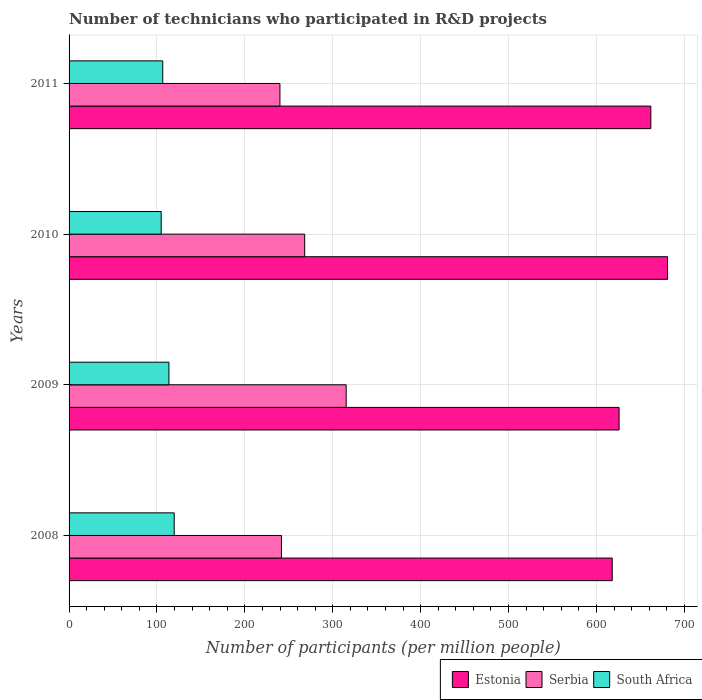How many different coloured bars are there?
Provide a succinct answer. 3. Are the number of bars per tick equal to the number of legend labels?
Provide a succinct answer. Yes. Are the number of bars on each tick of the Y-axis equal?
Your response must be concise. Yes. How many bars are there on the 3rd tick from the bottom?
Make the answer very short. 3. In how many cases, is the number of bars for a given year not equal to the number of legend labels?
Your response must be concise. 0. What is the number of technicians who participated in R&D projects in Estonia in 2009?
Provide a succinct answer. 625.74. Across all years, what is the maximum number of technicians who participated in R&D projects in South Africa?
Offer a very short reply. 119.61. Across all years, what is the minimum number of technicians who participated in R&D projects in South Africa?
Give a very brief answer. 104.79. In which year was the number of technicians who participated in R&D projects in South Africa maximum?
Keep it short and to the point. 2008. In which year was the number of technicians who participated in R&D projects in South Africa minimum?
Your answer should be compact. 2010. What is the total number of technicians who participated in R&D projects in Serbia in the graph?
Your response must be concise. 1064.76. What is the difference between the number of technicians who participated in R&D projects in Serbia in 2008 and that in 2011?
Your answer should be very brief. 1.69. What is the difference between the number of technicians who participated in R&D projects in Estonia in 2010 and the number of technicians who participated in R&D projects in Serbia in 2008?
Offer a terse response. 439.3. What is the average number of technicians who participated in R&D projects in South Africa per year?
Provide a short and direct response. 111.14. In the year 2011, what is the difference between the number of technicians who participated in R&D projects in South Africa and number of technicians who participated in R&D projects in Estonia?
Provide a succinct answer. -555.29. In how many years, is the number of technicians who participated in R&D projects in Estonia greater than 680 ?
Ensure brevity in your answer.  1. What is the ratio of the number of technicians who participated in R&D projects in Serbia in 2009 to that in 2010?
Give a very brief answer. 1.18. Is the number of technicians who participated in R&D projects in Serbia in 2010 less than that in 2011?
Ensure brevity in your answer.  No. What is the difference between the highest and the second highest number of technicians who participated in R&D projects in South Africa?
Your response must be concise. 6.02. What is the difference between the highest and the lowest number of technicians who participated in R&D projects in Serbia?
Your response must be concise. 75.36. In how many years, is the number of technicians who participated in R&D projects in Serbia greater than the average number of technicians who participated in R&D projects in Serbia taken over all years?
Give a very brief answer. 2. What does the 3rd bar from the top in 2011 represents?
Your answer should be very brief. Estonia. What does the 3rd bar from the bottom in 2008 represents?
Provide a succinct answer. South Africa. Is it the case that in every year, the sum of the number of technicians who participated in R&D projects in Serbia and number of technicians who participated in R&D projects in Estonia is greater than the number of technicians who participated in R&D projects in South Africa?
Provide a short and direct response. Yes. How many bars are there?
Offer a terse response. 12. Are all the bars in the graph horizontal?
Ensure brevity in your answer.  Yes. How many years are there in the graph?
Offer a terse response. 4. What is the difference between two consecutive major ticks on the X-axis?
Offer a very short reply. 100. Are the values on the major ticks of X-axis written in scientific E-notation?
Your answer should be compact. No. Does the graph contain any zero values?
Offer a terse response. No. Does the graph contain grids?
Your response must be concise. Yes. How many legend labels are there?
Your answer should be very brief. 3. How are the legend labels stacked?
Keep it short and to the point. Horizontal. What is the title of the graph?
Provide a succinct answer. Number of technicians who participated in R&D projects. What is the label or title of the X-axis?
Offer a terse response. Number of participants (per million people). What is the Number of participants (per million people) of Estonia in 2008?
Your answer should be very brief. 617.94. What is the Number of participants (per million people) of Serbia in 2008?
Your response must be concise. 241.58. What is the Number of participants (per million people) in South Africa in 2008?
Keep it short and to the point. 119.61. What is the Number of participants (per million people) of Estonia in 2009?
Offer a terse response. 625.74. What is the Number of participants (per million people) in Serbia in 2009?
Make the answer very short. 315.25. What is the Number of participants (per million people) in South Africa in 2009?
Provide a succinct answer. 113.59. What is the Number of participants (per million people) in Estonia in 2010?
Your answer should be very brief. 680.89. What is the Number of participants (per million people) in Serbia in 2010?
Make the answer very short. 268.03. What is the Number of participants (per million people) in South Africa in 2010?
Provide a short and direct response. 104.79. What is the Number of participants (per million people) in Estonia in 2011?
Make the answer very short. 661.86. What is the Number of participants (per million people) in Serbia in 2011?
Your answer should be very brief. 239.9. What is the Number of participants (per million people) in South Africa in 2011?
Your response must be concise. 106.57. Across all years, what is the maximum Number of participants (per million people) in Estonia?
Provide a succinct answer. 680.89. Across all years, what is the maximum Number of participants (per million people) of Serbia?
Your response must be concise. 315.25. Across all years, what is the maximum Number of participants (per million people) of South Africa?
Your answer should be compact. 119.61. Across all years, what is the minimum Number of participants (per million people) in Estonia?
Your answer should be very brief. 617.94. Across all years, what is the minimum Number of participants (per million people) of Serbia?
Your answer should be compact. 239.9. Across all years, what is the minimum Number of participants (per million people) of South Africa?
Keep it short and to the point. 104.79. What is the total Number of participants (per million people) in Estonia in the graph?
Provide a succinct answer. 2586.43. What is the total Number of participants (per million people) in Serbia in the graph?
Your answer should be compact. 1064.76. What is the total Number of participants (per million people) in South Africa in the graph?
Keep it short and to the point. 444.57. What is the difference between the Number of participants (per million people) of Estonia in 2008 and that in 2009?
Offer a terse response. -7.8. What is the difference between the Number of participants (per million people) of Serbia in 2008 and that in 2009?
Offer a very short reply. -73.67. What is the difference between the Number of participants (per million people) in South Africa in 2008 and that in 2009?
Make the answer very short. 6.02. What is the difference between the Number of participants (per million people) in Estonia in 2008 and that in 2010?
Your answer should be compact. -62.95. What is the difference between the Number of participants (per million people) of Serbia in 2008 and that in 2010?
Your answer should be very brief. -26.45. What is the difference between the Number of participants (per million people) in South Africa in 2008 and that in 2010?
Make the answer very short. 14.82. What is the difference between the Number of participants (per million people) of Estonia in 2008 and that in 2011?
Give a very brief answer. -43.93. What is the difference between the Number of participants (per million people) of Serbia in 2008 and that in 2011?
Make the answer very short. 1.69. What is the difference between the Number of participants (per million people) of South Africa in 2008 and that in 2011?
Ensure brevity in your answer.  13.04. What is the difference between the Number of participants (per million people) of Estonia in 2009 and that in 2010?
Your response must be concise. -55.14. What is the difference between the Number of participants (per million people) of Serbia in 2009 and that in 2010?
Provide a succinct answer. 47.22. What is the difference between the Number of participants (per million people) of South Africa in 2009 and that in 2010?
Provide a succinct answer. 8.8. What is the difference between the Number of participants (per million people) in Estonia in 2009 and that in 2011?
Keep it short and to the point. -36.12. What is the difference between the Number of participants (per million people) of Serbia in 2009 and that in 2011?
Give a very brief answer. 75.36. What is the difference between the Number of participants (per million people) in South Africa in 2009 and that in 2011?
Your answer should be very brief. 7.02. What is the difference between the Number of participants (per million people) in Estonia in 2010 and that in 2011?
Give a very brief answer. 19.02. What is the difference between the Number of participants (per million people) in Serbia in 2010 and that in 2011?
Give a very brief answer. 28.13. What is the difference between the Number of participants (per million people) in South Africa in 2010 and that in 2011?
Your response must be concise. -1.78. What is the difference between the Number of participants (per million people) in Estonia in 2008 and the Number of participants (per million people) in Serbia in 2009?
Provide a succinct answer. 302.69. What is the difference between the Number of participants (per million people) of Estonia in 2008 and the Number of participants (per million people) of South Africa in 2009?
Your response must be concise. 504.35. What is the difference between the Number of participants (per million people) in Serbia in 2008 and the Number of participants (per million people) in South Africa in 2009?
Offer a terse response. 127.99. What is the difference between the Number of participants (per million people) in Estonia in 2008 and the Number of participants (per million people) in Serbia in 2010?
Make the answer very short. 349.91. What is the difference between the Number of participants (per million people) in Estonia in 2008 and the Number of participants (per million people) in South Africa in 2010?
Ensure brevity in your answer.  513.14. What is the difference between the Number of participants (per million people) in Serbia in 2008 and the Number of participants (per million people) in South Africa in 2010?
Give a very brief answer. 136.79. What is the difference between the Number of participants (per million people) in Estonia in 2008 and the Number of participants (per million people) in Serbia in 2011?
Offer a very short reply. 378.04. What is the difference between the Number of participants (per million people) of Estonia in 2008 and the Number of participants (per million people) of South Africa in 2011?
Ensure brevity in your answer.  511.37. What is the difference between the Number of participants (per million people) of Serbia in 2008 and the Number of participants (per million people) of South Africa in 2011?
Give a very brief answer. 135.01. What is the difference between the Number of participants (per million people) in Estonia in 2009 and the Number of participants (per million people) in Serbia in 2010?
Give a very brief answer. 357.71. What is the difference between the Number of participants (per million people) of Estonia in 2009 and the Number of participants (per million people) of South Africa in 2010?
Provide a short and direct response. 520.95. What is the difference between the Number of participants (per million people) in Serbia in 2009 and the Number of participants (per million people) in South Africa in 2010?
Your response must be concise. 210.46. What is the difference between the Number of participants (per million people) in Estonia in 2009 and the Number of participants (per million people) in Serbia in 2011?
Ensure brevity in your answer.  385.85. What is the difference between the Number of participants (per million people) in Estonia in 2009 and the Number of participants (per million people) in South Africa in 2011?
Keep it short and to the point. 519.17. What is the difference between the Number of participants (per million people) of Serbia in 2009 and the Number of participants (per million people) of South Africa in 2011?
Give a very brief answer. 208.68. What is the difference between the Number of participants (per million people) in Estonia in 2010 and the Number of participants (per million people) in Serbia in 2011?
Provide a succinct answer. 440.99. What is the difference between the Number of participants (per million people) in Estonia in 2010 and the Number of participants (per million people) in South Africa in 2011?
Your response must be concise. 574.32. What is the difference between the Number of participants (per million people) in Serbia in 2010 and the Number of participants (per million people) in South Africa in 2011?
Your answer should be very brief. 161.46. What is the average Number of participants (per million people) in Estonia per year?
Make the answer very short. 646.61. What is the average Number of participants (per million people) in Serbia per year?
Your response must be concise. 266.19. What is the average Number of participants (per million people) of South Africa per year?
Your answer should be very brief. 111.14. In the year 2008, what is the difference between the Number of participants (per million people) in Estonia and Number of participants (per million people) in Serbia?
Offer a very short reply. 376.36. In the year 2008, what is the difference between the Number of participants (per million people) of Estonia and Number of participants (per million people) of South Africa?
Your answer should be very brief. 498.32. In the year 2008, what is the difference between the Number of participants (per million people) of Serbia and Number of participants (per million people) of South Africa?
Keep it short and to the point. 121.97. In the year 2009, what is the difference between the Number of participants (per million people) in Estonia and Number of participants (per million people) in Serbia?
Provide a short and direct response. 310.49. In the year 2009, what is the difference between the Number of participants (per million people) in Estonia and Number of participants (per million people) in South Africa?
Your answer should be very brief. 512.15. In the year 2009, what is the difference between the Number of participants (per million people) of Serbia and Number of participants (per million people) of South Africa?
Offer a very short reply. 201.66. In the year 2010, what is the difference between the Number of participants (per million people) of Estonia and Number of participants (per million people) of Serbia?
Give a very brief answer. 412.86. In the year 2010, what is the difference between the Number of participants (per million people) of Estonia and Number of participants (per million people) of South Africa?
Your answer should be compact. 576.09. In the year 2010, what is the difference between the Number of participants (per million people) of Serbia and Number of participants (per million people) of South Africa?
Your answer should be very brief. 163.24. In the year 2011, what is the difference between the Number of participants (per million people) in Estonia and Number of participants (per million people) in Serbia?
Your answer should be compact. 421.97. In the year 2011, what is the difference between the Number of participants (per million people) of Estonia and Number of participants (per million people) of South Africa?
Give a very brief answer. 555.29. In the year 2011, what is the difference between the Number of participants (per million people) in Serbia and Number of participants (per million people) in South Africa?
Your response must be concise. 133.33. What is the ratio of the Number of participants (per million people) of Estonia in 2008 to that in 2009?
Ensure brevity in your answer.  0.99. What is the ratio of the Number of participants (per million people) of Serbia in 2008 to that in 2009?
Keep it short and to the point. 0.77. What is the ratio of the Number of participants (per million people) of South Africa in 2008 to that in 2009?
Provide a short and direct response. 1.05. What is the ratio of the Number of participants (per million people) of Estonia in 2008 to that in 2010?
Give a very brief answer. 0.91. What is the ratio of the Number of participants (per million people) of Serbia in 2008 to that in 2010?
Your response must be concise. 0.9. What is the ratio of the Number of participants (per million people) of South Africa in 2008 to that in 2010?
Offer a very short reply. 1.14. What is the ratio of the Number of participants (per million people) of Estonia in 2008 to that in 2011?
Keep it short and to the point. 0.93. What is the ratio of the Number of participants (per million people) of Serbia in 2008 to that in 2011?
Your answer should be very brief. 1.01. What is the ratio of the Number of participants (per million people) of South Africa in 2008 to that in 2011?
Give a very brief answer. 1.12. What is the ratio of the Number of participants (per million people) of Estonia in 2009 to that in 2010?
Your response must be concise. 0.92. What is the ratio of the Number of participants (per million people) of Serbia in 2009 to that in 2010?
Keep it short and to the point. 1.18. What is the ratio of the Number of participants (per million people) in South Africa in 2009 to that in 2010?
Keep it short and to the point. 1.08. What is the ratio of the Number of participants (per million people) in Estonia in 2009 to that in 2011?
Your response must be concise. 0.95. What is the ratio of the Number of participants (per million people) in Serbia in 2009 to that in 2011?
Offer a very short reply. 1.31. What is the ratio of the Number of participants (per million people) of South Africa in 2009 to that in 2011?
Provide a succinct answer. 1.07. What is the ratio of the Number of participants (per million people) of Estonia in 2010 to that in 2011?
Your response must be concise. 1.03. What is the ratio of the Number of participants (per million people) of Serbia in 2010 to that in 2011?
Your answer should be very brief. 1.12. What is the ratio of the Number of participants (per million people) of South Africa in 2010 to that in 2011?
Ensure brevity in your answer.  0.98. What is the difference between the highest and the second highest Number of participants (per million people) of Estonia?
Your answer should be compact. 19.02. What is the difference between the highest and the second highest Number of participants (per million people) of Serbia?
Offer a terse response. 47.22. What is the difference between the highest and the second highest Number of participants (per million people) of South Africa?
Your answer should be compact. 6.02. What is the difference between the highest and the lowest Number of participants (per million people) in Estonia?
Ensure brevity in your answer.  62.95. What is the difference between the highest and the lowest Number of participants (per million people) in Serbia?
Offer a terse response. 75.36. What is the difference between the highest and the lowest Number of participants (per million people) of South Africa?
Your answer should be very brief. 14.82. 